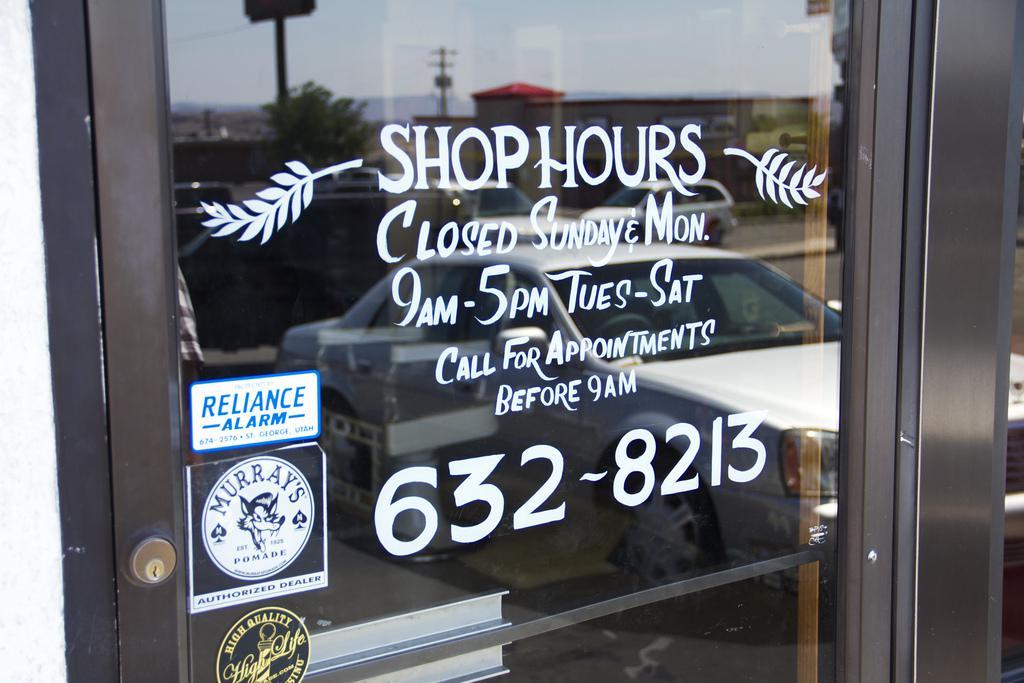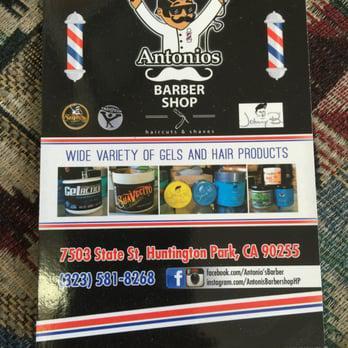The first image is the image on the left, the second image is the image on the right. For the images shown, is this caption "In at least one image there are three people getting their haircut." true? Answer yes or no. No. 